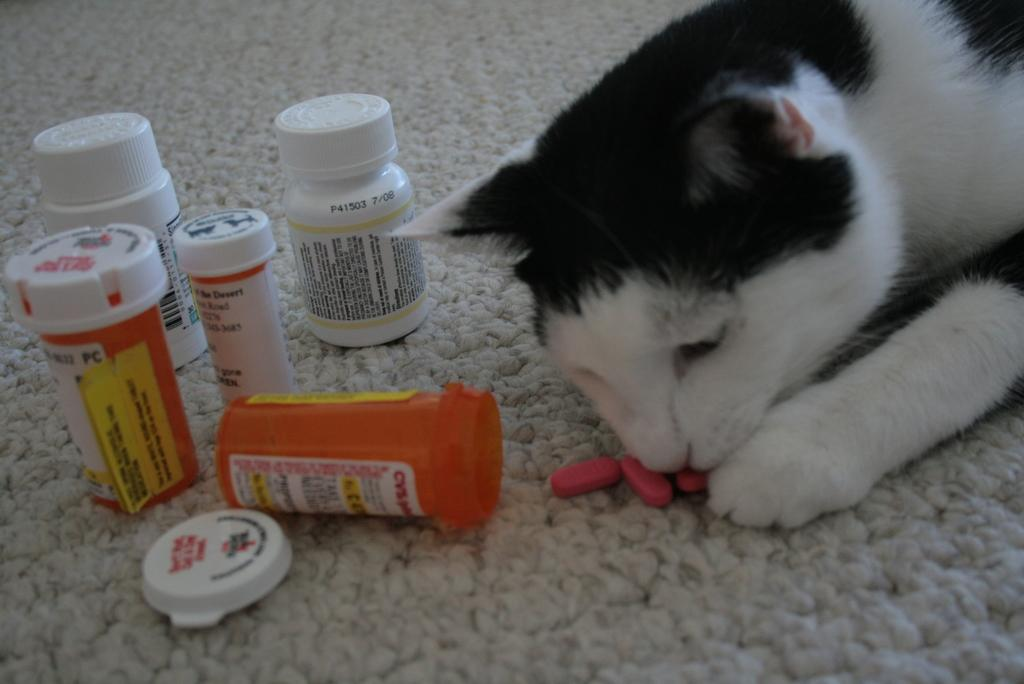What animal is present in the image? There is a cat in the image. What is the cat doing in the image? The cat is smelling capsules. Where are the capsules located in the image? The capsules are on a carpet. Are there any containers for the capsules in the image? Yes, there are capsule boxes on the carpet. How is the cat helping to treat the wound in the image? There is no wound present in the image, and the cat is not shown providing any treatment. 